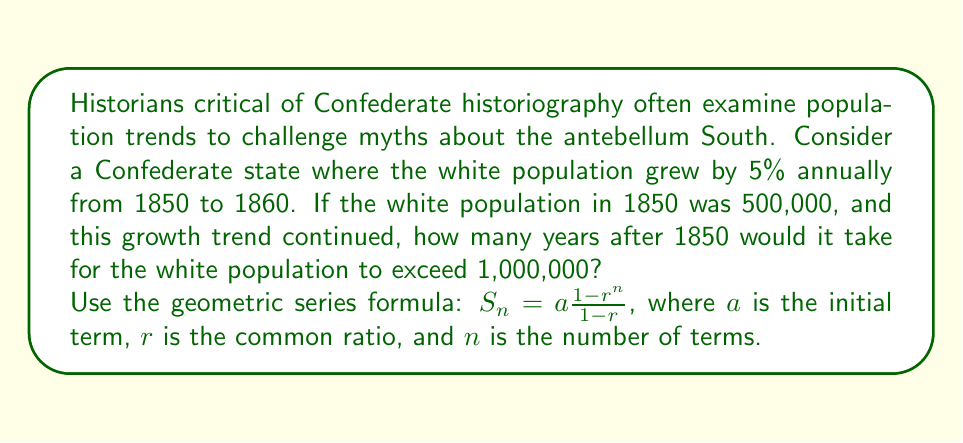Could you help me with this problem? Let's approach this step-by-step:

1) We're dealing with a geometric sequence where:
   $a = 500,000$ (initial population)
   $r = 1.05$ (5% growth = 1 + 0.05)

2) We need to find $n$ where the population exceeds 1,000,000. Let's set up the inequality:

   $500,000 * (1.05)^n > 1,000,000$

3) Dividing both sides by 500,000:

   $(1.05)^n > 2$

4) Taking the natural log of both sides:

   $n * \ln(1.05) > \ln(2)$

5) Solving for $n$:

   $n > \frac{\ln(2)}{\ln(1.05)}$

6) Using a calculator:

   $n > 14.2067...$

7) Since $n$ must be a whole number of years, we round up to the next integer.
Answer: 15 years 